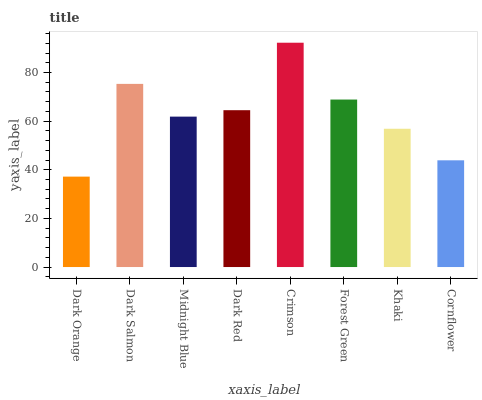Is Dark Orange the minimum?
Answer yes or no. Yes. Is Crimson the maximum?
Answer yes or no. Yes. Is Dark Salmon the minimum?
Answer yes or no. No. Is Dark Salmon the maximum?
Answer yes or no. No. Is Dark Salmon greater than Dark Orange?
Answer yes or no. Yes. Is Dark Orange less than Dark Salmon?
Answer yes or no. Yes. Is Dark Orange greater than Dark Salmon?
Answer yes or no. No. Is Dark Salmon less than Dark Orange?
Answer yes or no. No. Is Dark Red the high median?
Answer yes or no. Yes. Is Midnight Blue the low median?
Answer yes or no. Yes. Is Dark Orange the high median?
Answer yes or no. No. Is Khaki the low median?
Answer yes or no. No. 